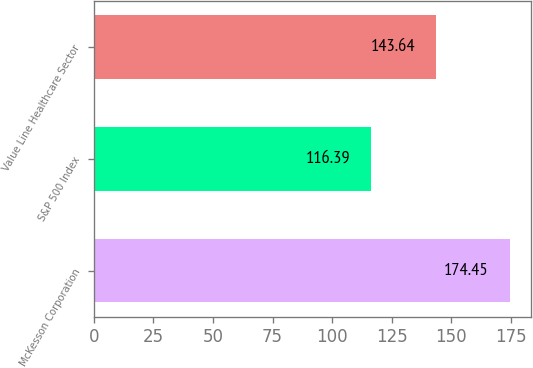Convert chart to OTSL. <chart><loc_0><loc_0><loc_500><loc_500><bar_chart><fcel>McKesson Corporation<fcel>S&P 500 Index<fcel>Value Line Healthcare Sector<nl><fcel>174.45<fcel>116.39<fcel>143.64<nl></chart> 